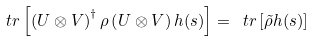<formula> <loc_0><loc_0><loc_500><loc_500>\ t r \left [ \left ( U \otimes V \right ) ^ { \dagger } \rho \left ( U \otimes V \right ) h ( s ) \right ] = \ t r \left [ \tilde { \rho } h ( s ) \right ]</formula> 